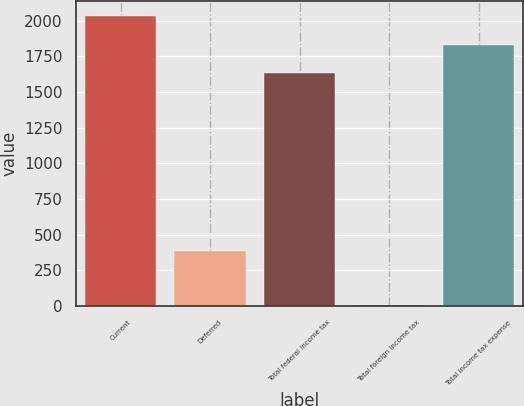Convert chart. <chart><loc_0><loc_0><loc_500><loc_500><bar_chart><fcel>Current<fcel>Deferred<fcel>Total federal income tax<fcel>Total foreign income tax<fcel>Total income tax expense<nl><fcel>2034.8<fcel>387<fcel>1633<fcel>11<fcel>1833.9<nl></chart> 